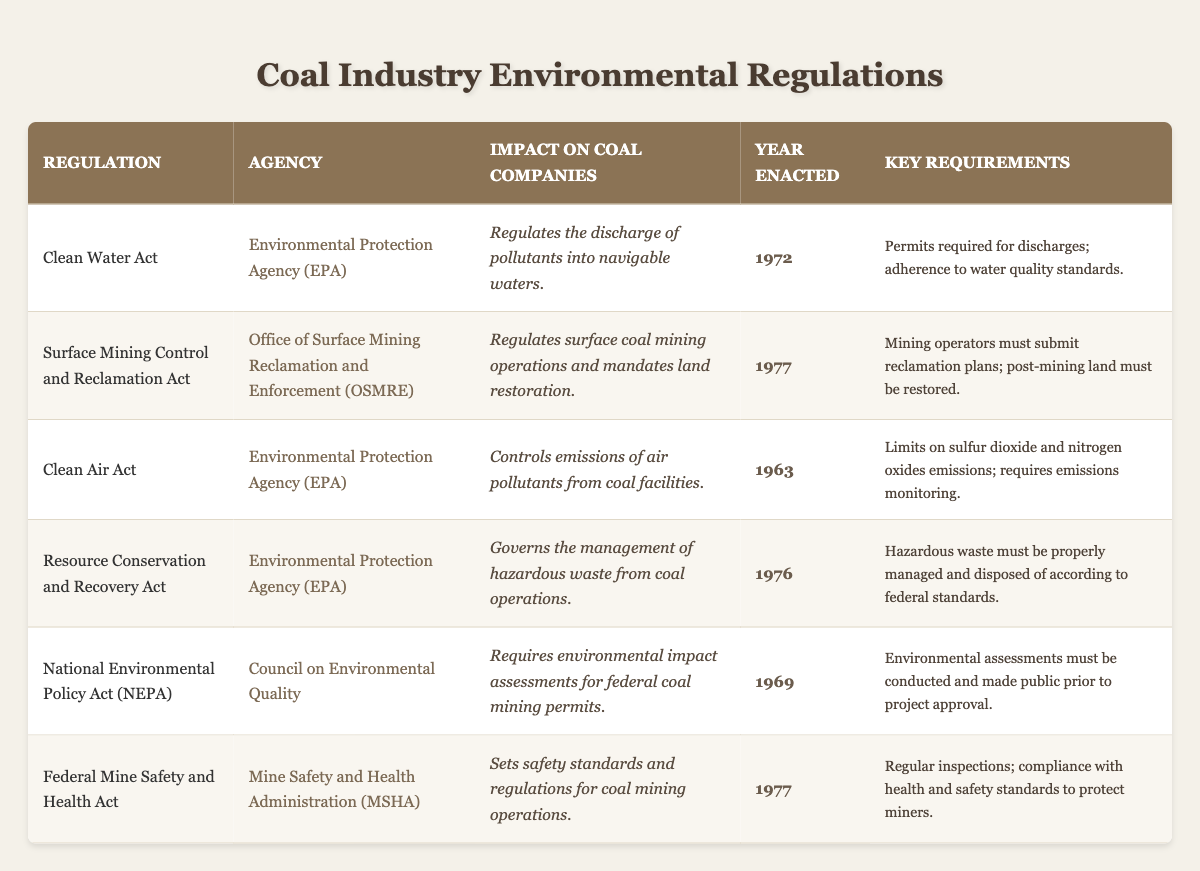What is the year the Clean Water Act was enacted? The Clean Water Act is listed in the table under the regulation name, with its year of enactment specified in the corresponding column. It shows that this act was enacted in 1972.
Answer: 1972 Which agency enforces the Surface Mining Control and Reclamation Act? The table indicates that the enforcement agency for the Surface Mining Control and Reclamation Act is the Office of Surface Mining Reclamation and Enforcement (OSMRE), as shown in the respective column for that regulation.
Answer: Office of Surface Mining Reclamation and Enforcement (OSMRE) What are the key requirements of the Resource Conservation and Recovery Act? To find the key requirements, I look at the row for the Resource Conservation and Recovery Act. The table states that hazardous waste must be properly managed and disposed of according to federal standards.
Answer: Hazardous waste must be properly managed and disposed of according to federal standards How many environmental regulations were enacted after 1975? First, I check the year enacted for each regulation. The regulations enacted after 1975 are the Surface Mining Control and Reclamation Act (1977) and the Federal Mine Safety and Health Act (1977). This gives us a total of 2 regulations.
Answer: 2 Is the Clean Air Act related to controlling emissions of air pollutants? According to the table, the impact on coal companies from the Clean Air Act is specified as controlling emissions of air pollutants from coal facilities, thus confirming the relevance of the act to air pollution control.
Answer: Yes What is the impact of the National Environmental Policy Act (NEPA) on coal companies? The NEPA's impact is listed in the table, stating that it requires environmental impact assessments for federal coal mining permits. To answer, I refer to this description to conclude its relevance for coal operations.
Answer: Requires environmental impact assessments for federal coal mining permits Which regulation has the earliest year of enactment? By reviewing the "Year Enacted" column, I can see that the Clean Air Act with a year of 1963 has the earliest date compared to all other regulations listed.
Answer: Clean Air Act How many regulations are enforced by the Environmental Protection Agency (EPA)? To find this, I count the regulations enforced by the EPA listed in the table: Clean Water Act, Clean Air Act, and Resource Conservation and Recovery Act, totaling 3 regulations enforced by the EPA.
Answer: 3 What is the key requirement of the Federal Mine Safety and Health Act? Referring to the corresponding section in the table for the Federal Mine Safety and Health Act, it specifies that there must be regular inspections and compliance with health and safety standards to protect miners.
Answer: Regular inspections; compliance with health and safety standards to protect miners 